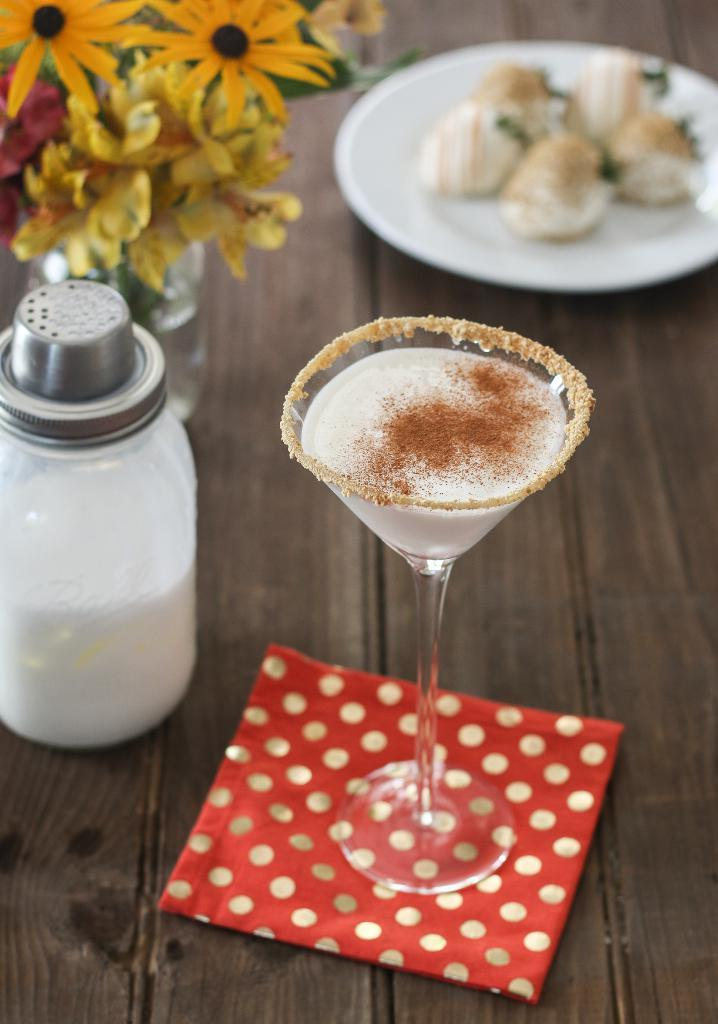What type of table is in the picture? There is a wooden table in the picture. What is placed on the wooden table? There is a plate, a flower vase, a salt bottle, and a glass on the wooden table. Can you describe the objects on the wooden table? The plate, flower vase, salt bottle, and glass are the objects on the wooden table. What is the opinion of the eggs in the image? There are no eggs present in the image, so it is not possible to determine their opinion. 